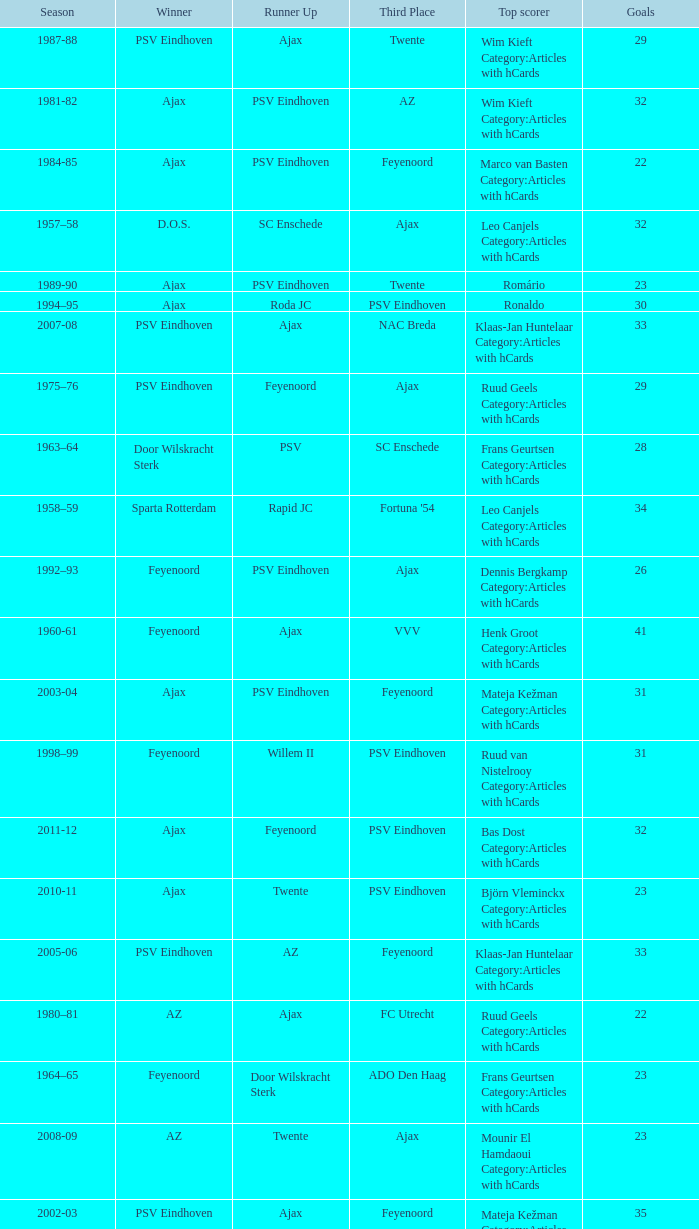When nac breda came in third place and psv eindhoven was the winner who is the top scorer? Klaas-Jan Huntelaar Category:Articles with hCards. 